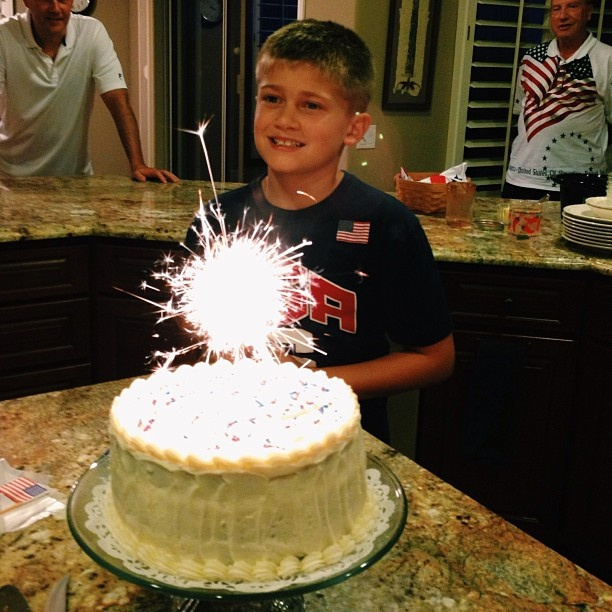Describe the objects in this image and their specific colors. I can see dining table in tan, olive, and white tones, people in tan, black, brown, and maroon tones, cake in tan, white, and olive tones, people in tan, olive, maroon, gray, and black tones, and people in tan, black, gray, darkgray, and maroon tones in this image. 